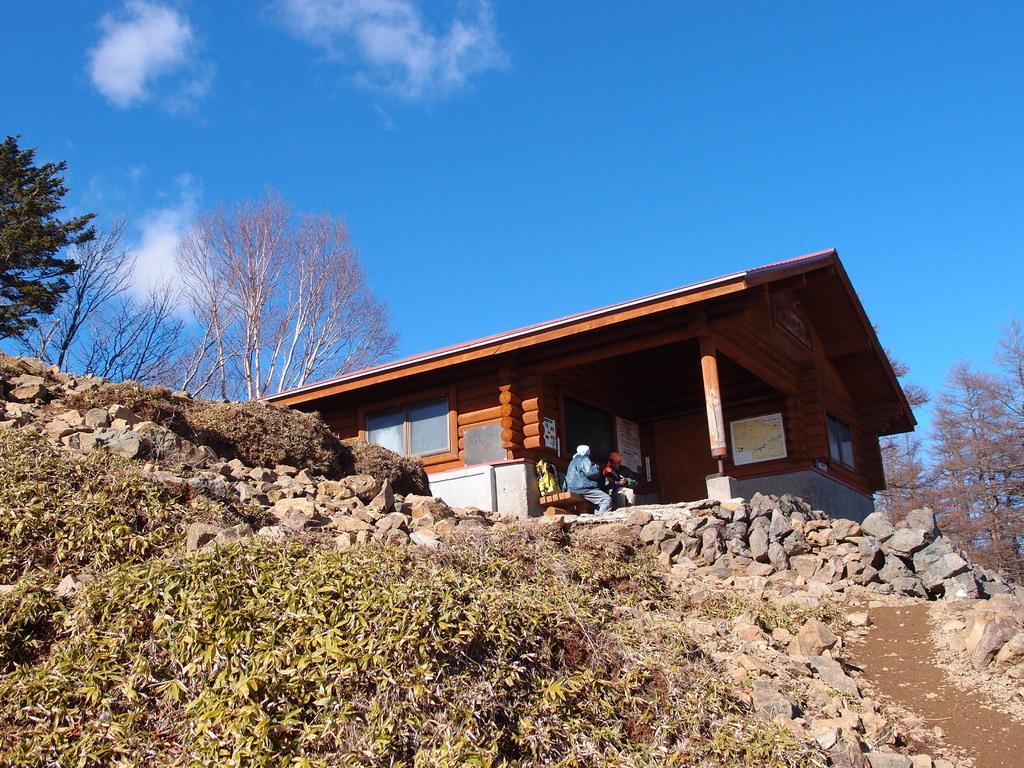What type of house is in the image? There is a wooden house in the image. What natural elements can be seen in the image? There are trees, grass, and stones in the image. What is visible in the sky in the image? The sky is visible in the image, and clouds are present. Can you describe the setting where the wooden house is located? The wooden house is located in a natural environment with trees, grass, and stones. How many people are in the image? There are two persons sitting on a bench in the image. What time does the clock show in the image? There is no clock present in the image. What part of the body can be seen on the elbow of the person sitting on the bench? There is no elbow visible in the image, as the persons are sitting on a bench with their arms likely resting on their laps or the bench. 